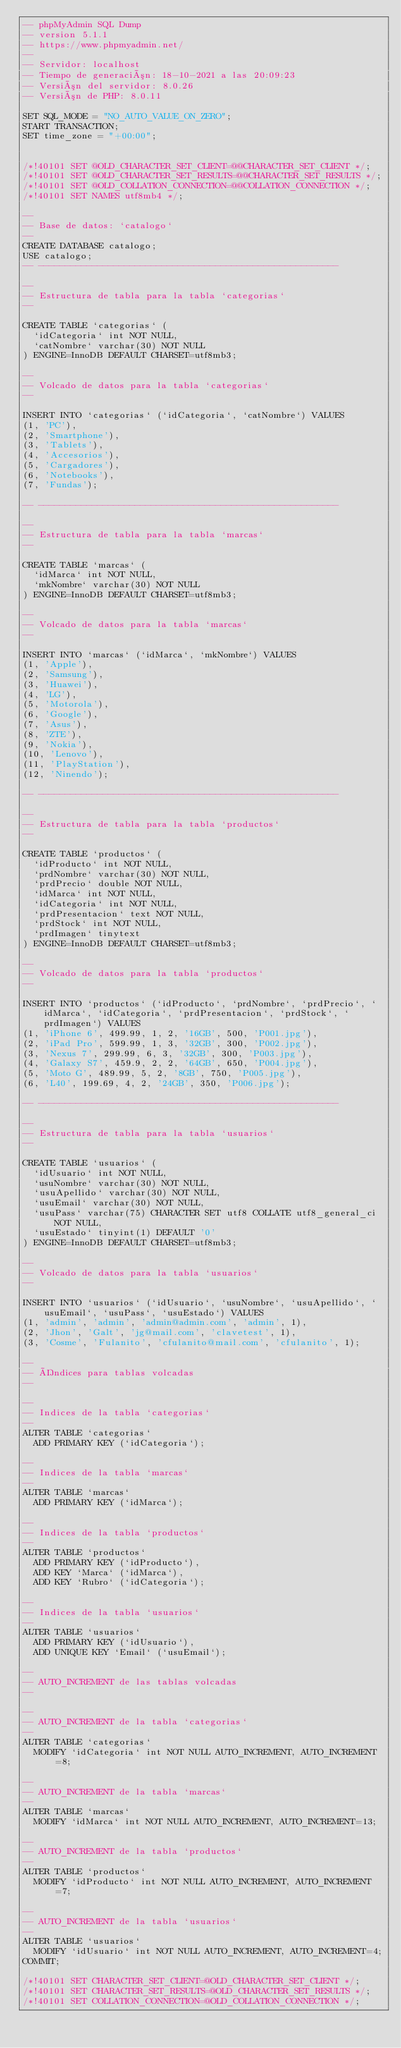Convert code to text. <code><loc_0><loc_0><loc_500><loc_500><_SQL_>-- phpMyAdmin SQL Dump
-- version 5.1.1
-- https://www.phpmyadmin.net/
--
-- Servidor: localhost
-- Tiempo de generación: 18-10-2021 a las 20:09:23
-- Versión del servidor: 8.0.26
-- Versión de PHP: 8.0.11

SET SQL_MODE = "NO_AUTO_VALUE_ON_ZERO";
START TRANSACTION;
SET time_zone = "+00:00";


/*!40101 SET @OLD_CHARACTER_SET_CLIENT=@@CHARACTER_SET_CLIENT */;
/*!40101 SET @OLD_CHARACTER_SET_RESULTS=@@CHARACTER_SET_RESULTS */;
/*!40101 SET @OLD_COLLATION_CONNECTION=@@COLLATION_CONNECTION */;
/*!40101 SET NAMES utf8mb4 */;

--
-- Base de datos: `catalogo`
--
CREATE DATABASE catalogo;
USE catalogo;
-- --------------------------------------------------------

--
-- Estructura de tabla para la tabla `categorias`
--

CREATE TABLE `categorias` (
  `idCategoria` int NOT NULL,
  `catNombre` varchar(30) NOT NULL
) ENGINE=InnoDB DEFAULT CHARSET=utf8mb3;

--
-- Volcado de datos para la tabla `categorias`
--

INSERT INTO `categorias` (`idCategoria`, `catNombre`) VALUES
(1, 'PC'),
(2, 'Smartphone'),
(3, 'Tablets'),
(4, 'Accesorios'),
(5, 'Cargadores'),
(6, 'Notebooks'),
(7, 'Fundas');

-- --------------------------------------------------------

--
-- Estructura de tabla para la tabla `marcas`
--

CREATE TABLE `marcas` (
  `idMarca` int NOT NULL,
  `mkNombre` varchar(30) NOT NULL
) ENGINE=InnoDB DEFAULT CHARSET=utf8mb3;

--
-- Volcado de datos para la tabla `marcas`
--

INSERT INTO `marcas` (`idMarca`, `mkNombre`) VALUES
(1, 'Apple'),
(2, 'Samsung'),
(3, 'Huawei'),
(4, 'LG'),
(5, 'Motorola'),
(6, 'Google'),
(7, 'Asus'),
(8, 'ZTE'),
(9, 'Nokia'),
(10, 'Lenovo'),
(11, 'PlayStation'),
(12, 'Ninendo');

-- --------------------------------------------------------

--
-- Estructura de tabla para la tabla `productos`
--

CREATE TABLE `productos` (
  `idProducto` int NOT NULL,
  `prdNombre` varchar(30) NOT NULL,
  `prdPrecio` double NOT NULL,
  `idMarca` int NOT NULL,
  `idCategoria` int NOT NULL,
  `prdPresentacion` text NOT NULL,
  `prdStock` int NOT NULL,
  `prdImagen` tinytext
) ENGINE=InnoDB DEFAULT CHARSET=utf8mb3;

--
-- Volcado de datos para la tabla `productos`
--

INSERT INTO `productos` (`idProducto`, `prdNombre`, `prdPrecio`, `idMarca`, `idCategoria`, `prdPresentacion`, `prdStock`, `prdImagen`) VALUES
(1, 'iPhone 6', 499.99, 1, 2, '16GB', 500, 'P001.jpg'),
(2, 'iPad Pro', 599.99, 1, 3, '32GB', 300, 'P002.jpg'),
(3, 'Nexus 7', 299.99, 6, 3, '32GB', 300, 'P003.jpg'),
(4, 'Galaxy S7', 459.9, 2, 2, '64GB', 650, 'P004.jpg'),
(5, 'Moto G', 489.99, 5, 2, '8GB', 750, 'P005.jpg'),
(6, 'L40', 199.69, 4, 2, '24GB', 350, 'P006.jpg');

-- --------------------------------------------------------

--
-- Estructura de tabla para la tabla `usuarios`
--

CREATE TABLE `usuarios` (
  `idUsuario` int NOT NULL,
  `usuNombre` varchar(30) NOT NULL,
  `usuApellido` varchar(30) NOT NULL,
  `usuEmail` varchar(30) NOT NULL,
  `usuPass` varchar(75) CHARACTER SET utf8 COLLATE utf8_general_ci NOT NULL,
  `usuEstado` tinyint(1) DEFAULT '0'
) ENGINE=InnoDB DEFAULT CHARSET=utf8mb3;

--
-- Volcado de datos para la tabla `usuarios`
--

INSERT INTO `usuarios` (`idUsuario`, `usuNombre`, `usuApellido`, `usuEmail`, `usuPass`, `usuEstado`) VALUES
(1, 'admin', 'admin', 'admin@admin.com', 'admin', 1),
(2, 'Jhon', 'Galt', 'jg@mail.com', 'clavetest', 1),
(3, 'Cosme', 'Fulanito', 'cfulanito@mail.com', 'cfulanito', 1);

--
-- Índices para tablas volcadas
--

--
-- Indices de la tabla `categorias`
--
ALTER TABLE `categorias`
  ADD PRIMARY KEY (`idCategoria`);

--
-- Indices de la tabla `marcas`
--
ALTER TABLE `marcas`
  ADD PRIMARY KEY (`idMarca`);

--
-- Indices de la tabla `productos`
--
ALTER TABLE `productos`
  ADD PRIMARY KEY (`idProducto`),
  ADD KEY `Marca` (`idMarca`),
  ADD KEY `Rubro` (`idCategoria`);

--
-- Indices de la tabla `usuarios`
--
ALTER TABLE `usuarios`
  ADD PRIMARY KEY (`idUsuario`),
  ADD UNIQUE KEY `Email` (`usuEmail`);

--
-- AUTO_INCREMENT de las tablas volcadas
--

--
-- AUTO_INCREMENT de la tabla `categorias`
--
ALTER TABLE `categorias`
  MODIFY `idCategoria` int NOT NULL AUTO_INCREMENT, AUTO_INCREMENT=8;

--
-- AUTO_INCREMENT de la tabla `marcas`
--
ALTER TABLE `marcas`
  MODIFY `idMarca` int NOT NULL AUTO_INCREMENT, AUTO_INCREMENT=13;

--
-- AUTO_INCREMENT de la tabla `productos`
--
ALTER TABLE `productos`
  MODIFY `idProducto` int NOT NULL AUTO_INCREMENT, AUTO_INCREMENT=7;

--
-- AUTO_INCREMENT de la tabla `usuarios`
--
ALTER TABLE `usuarios`
  MODIFY `idUsuario` int NOT NULL AUTO_INCREMENT, AUTO_INCREMENT=4;
COMMIT;

/*!40101 SET CHARACTER_SET_CLIENT=@OLD_CHARACTER_SET_CLIENT */;
/*!40101 SET CHARACTER_SET_RESULTS=@OLD_CHARACTER_SET_RESULTS */;
/*!40101 SET COLLATION_CONNECTION=@OLD_COLLATION_CONNECTION */;
</code> 